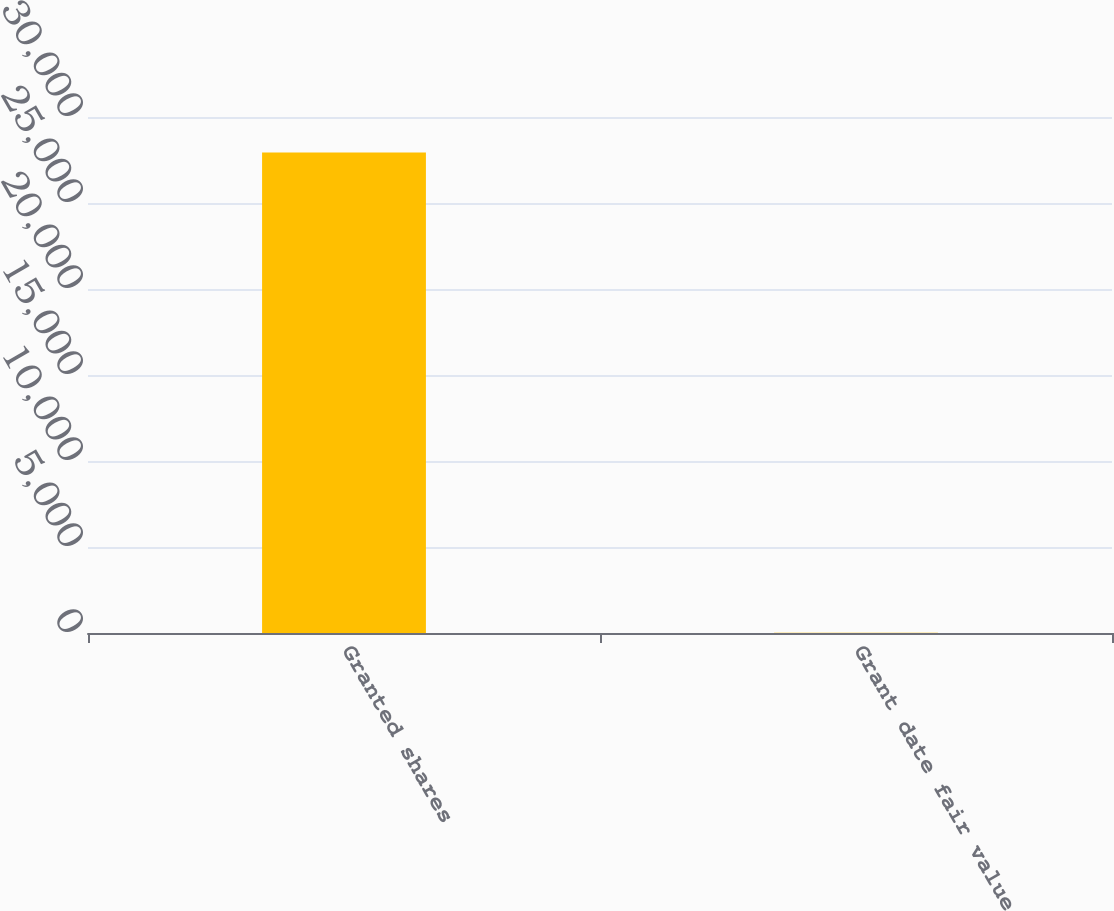<chart> <loc_0><loc_0><loc_500><loc_500><bar_chart><fcel>Granted shares<fcel>Grant date fair value<nl><fcel>27931<fcel>20.62<nl></chart> 